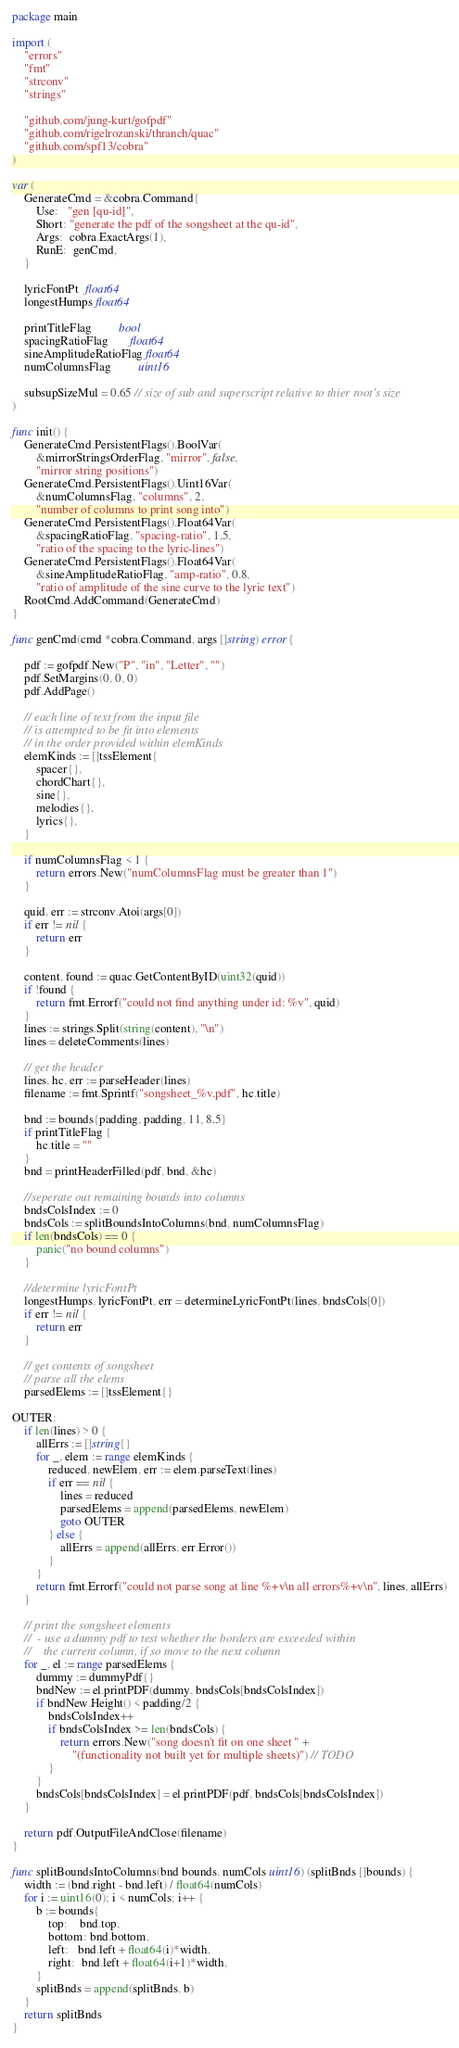<code> <loc_0><loc_0><loc_500><loc_500><_Go_>package main

import (
	"errors"
	"fmt"
	"strconv"
	"strings"

	"github.com/jung-kurt/gofpdf"
	"github.com/rigelrozanski/thranch/quac"
	"github.com/spf13/cobra"
)

var (
	GenerateCmd = &cobra.Command{
		Use:   "gen [qu-id]",
		Short: "generate the pdf of the songsheet at the qu-id",
		Args:  cobra.ExactArgs(1),
		RunE:  genCmd,
	}

	lyricFontPt  float64
	longestHumps float64

	printTitleFlag         bool
	spacingRatioFlag       float64
	sineAmplitudeRatioFlag float64
	numColumnsFlag         uint16

	subsupSizeMul = 0.65 // size of sub and superscript relative to thier root's size
)

func init() {
	GenerateCmd.PersistentFlags().BoolVar(
		&mirrorStringsOrderFlag, "mirror", false,
		"mirror string positions")
	GenerateCmd.PersistentFlags().Uint16Var(
		&numColumnsFlag, "columns", 2,
		"number of columns to print song into")
	GenerateCmd.PersistentFlags().Float64Var(
		&spacingRatioFlag, "spacing-ratio", 1.5,
		"ratio of the spacing to the lyric-lines")
	GenerateCmd.PersistentFlags().Float64Var(
		&sineAmplitudeRatioFlag, "amp-ratio", 0.8,
		"ratio of amplitude of the sine curve to the lyric text")
	RootCmd.AddCommand(GenerateCmd)
}

func genCmd(cmd *cobra.Command, args []string) error {

	pdf := gofpdf.New("P", "in", "Letter", "")
	pdf.SetMargins(0, 0, 0)
	pdf.AddPage()

	// each line of text from the input file
	// is attempted to be fit into elements
	// in the order provided within elemKinds
	elemKinds := []tssElement{
		spacer{},
		chordChart{},
		sine{},
		melodies{},
		lyrics{},
	}

	if numColumnsFlag < 1 {
		return errors.New("numColumnsFlag must be greater than 1")
	}

	quid, err := strconv.Atoi(args[0])
	if err != nil {
		return err
	}

	content, found := quac.GetContentByID(uint32(quid))
	if !found {
		return fmt.Errorf("could not find anything under id: %v", quid)
	}
	lines := strings.Split(string(content), "\n")
	lines = deleteComments(lines)

	// get the header
	lines, hc, err := parseHeader(lines)
	filename := fmt.Sprintf("songsheet_%v.pdf", hc.title)

	bnd := bounds{padding, padding, 11, 8.5}
	if printTitleFlag {
		hc.title = ""
	}
	bnd = printHeaderFilled(pdf, bnd, &hc)

	//seperate out remaining bounds into columns
	bndsColsIndex := 0
	bndsCols := splitBoundsIntoColumns(bnd, numColumnsFlag)
	if len(bndsCols) == 0 {
		panic("no bound columns")
	}

	//determine lyricFontPt
	longestHumps, lyricFontPt, err = determineLyricFontPt(lines, bndsCols[0])
	if err != nil {
		return err
	}

	// get contents of songsheet
	// parse all the elems
	parsedElems := []tssElement{}

OUTER:
	if len(lines) > 0 {
		allErrs := []string{}
		for _, elem := range elemKinds {
			reduced, newElem, err := elem.parseText(lines)
			if err == nil {
				lines = reduced
				parsedElems = append(parsedElems, newElem)
				goto OUTER
			} else {
				allErrs = append(allErrs, err.Error())
			}
		}
		return fmt.Errorf("could not parse song at line %+v\n all errors%+v\n", lines, allErrs)
	}

	// print the songsheet elements
	//  - use a dummy pdf to test whether the borders are exceeded within
	//    the current column, if so move to the next column
	for _, el := range parsedElems {
		dummy := dummyPdf{}
		bndNew := el.printPDF(dummy, bndsCols[bndsColsIndex])
		if bndNew.Height() < padding/2 {
			bndsColsIndex++
			if bndsColsIndex >= len(bndsCols) {
				return errors.New("song doesn't fit on one sheet " +
					"(functionality not built yet for multiple sheets)") // TODO
			}
		}
		bndsCols[bndsColsIndex] = el.printPDF(pdf, bndsCols[bndsColsIndex])
	}

	return pdf.OutputFileAndClose(filename)
}

func splitBoundsIntoColumns(bnd bounds, numCols uint16) (splitBnds []bounds) {
	width := (bnd.right - bnd.left) / float64(numCols)
	for i := uint16(0); i < numCols; i++ {
		b := bounds{
			top:    bnd.top,
			bottom: bnd.bottom,
			left:   bnd.left + float64(i)*width,
			right:  bnd.left + float64(i+1)*width,
		}
		splitBnds = append(splitBnds, b)
	}
	return splitBnds
}
</code> 